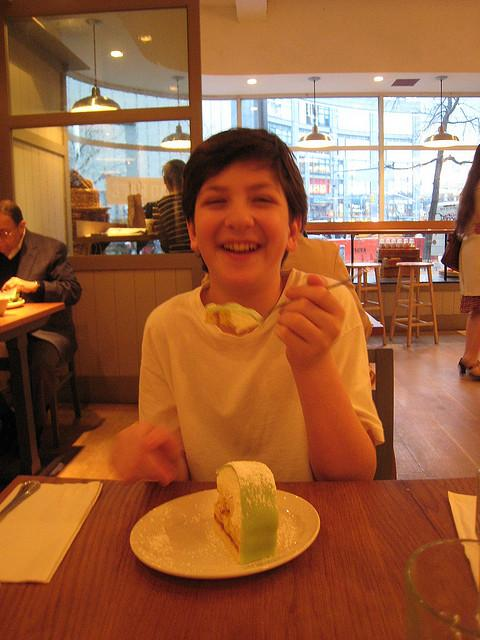What is this cake called? Please explain your reasoning. princess cake. It's green and has layers. 